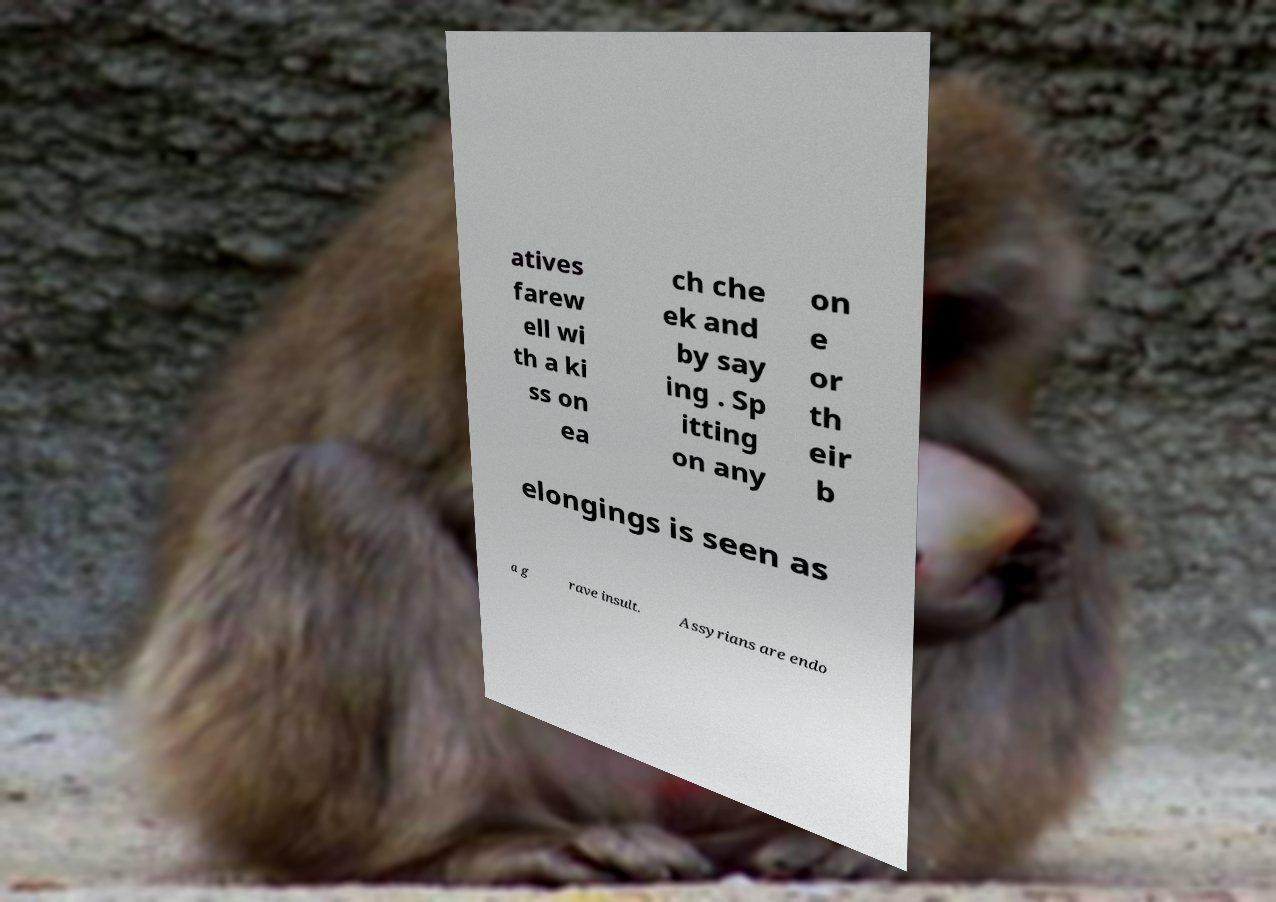Could you assist in decoding the text presented in this image and type it out clearly? atives farew ell wi th a ki ss on ea ch che ek and by say ing . Sp itting on any on e or th eir b elongings is seen as a g rave insult. Assyrians are endo 